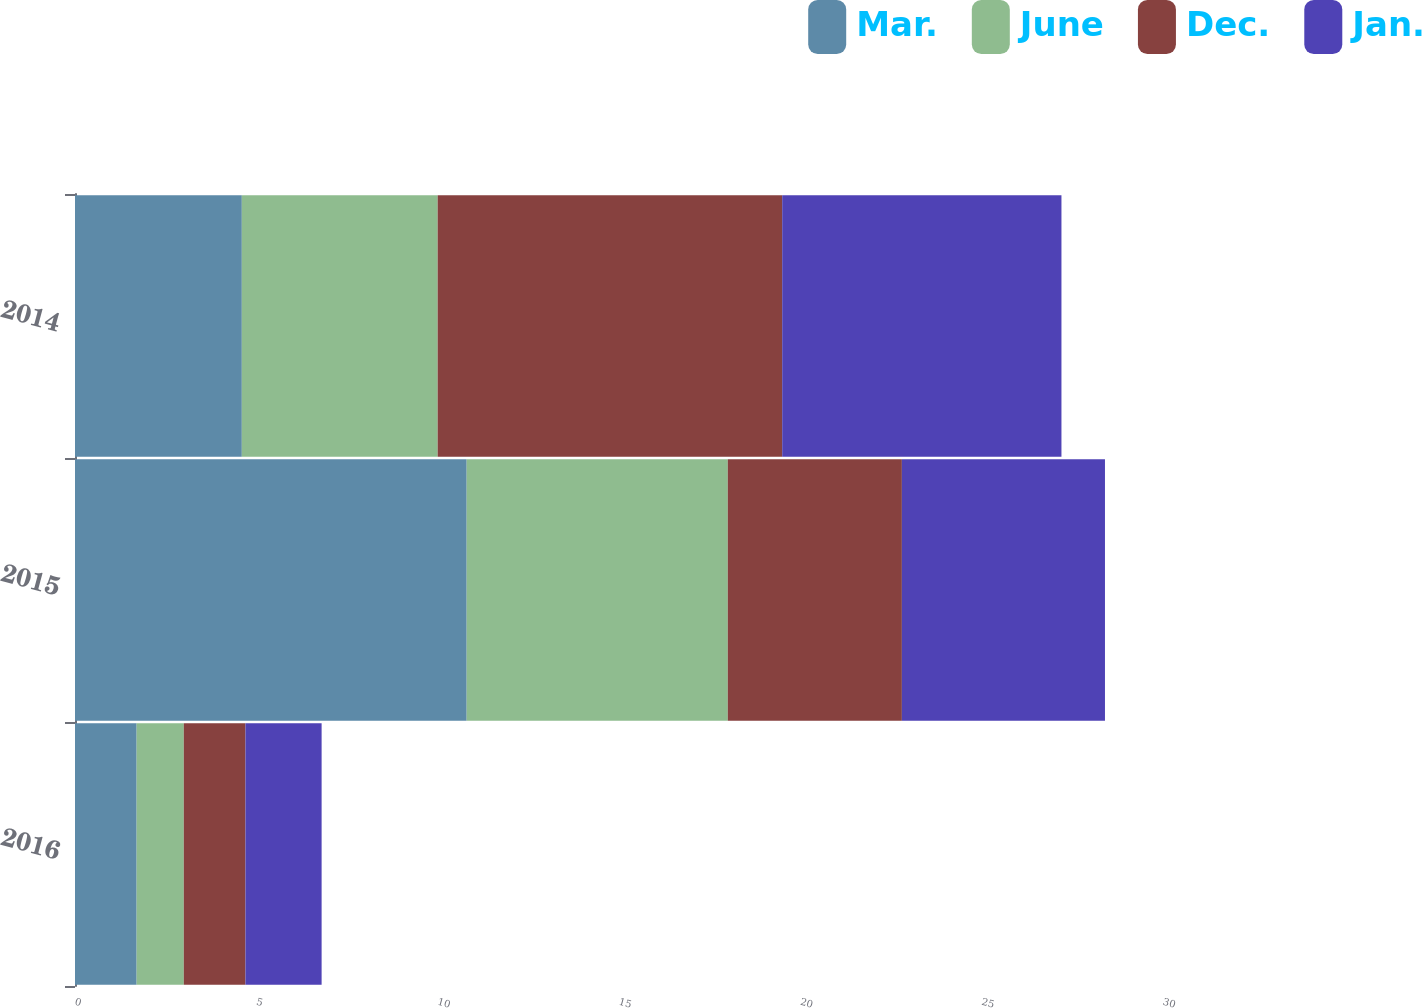Convert chart to OTSL. <chart><loc_0><loc_0><loc_500><loc_500><stacked_bar_chart><ecel><fcel>2016<fcel>2015<fcel>2014<nl><fcel>Mar.<fcel>1.7<fcel>10.8<fcel>4.6<nl><fcel>June<fcel>1.3<fcel>7.2<fcel>5.4<nl><fcel>Dec.<fcel>1.7<fcel>4.8<fcel>9.5<nl><fcel>Jan.<fcel>2.1<fcel>5.6<fcel>7.7<nl></chart> 